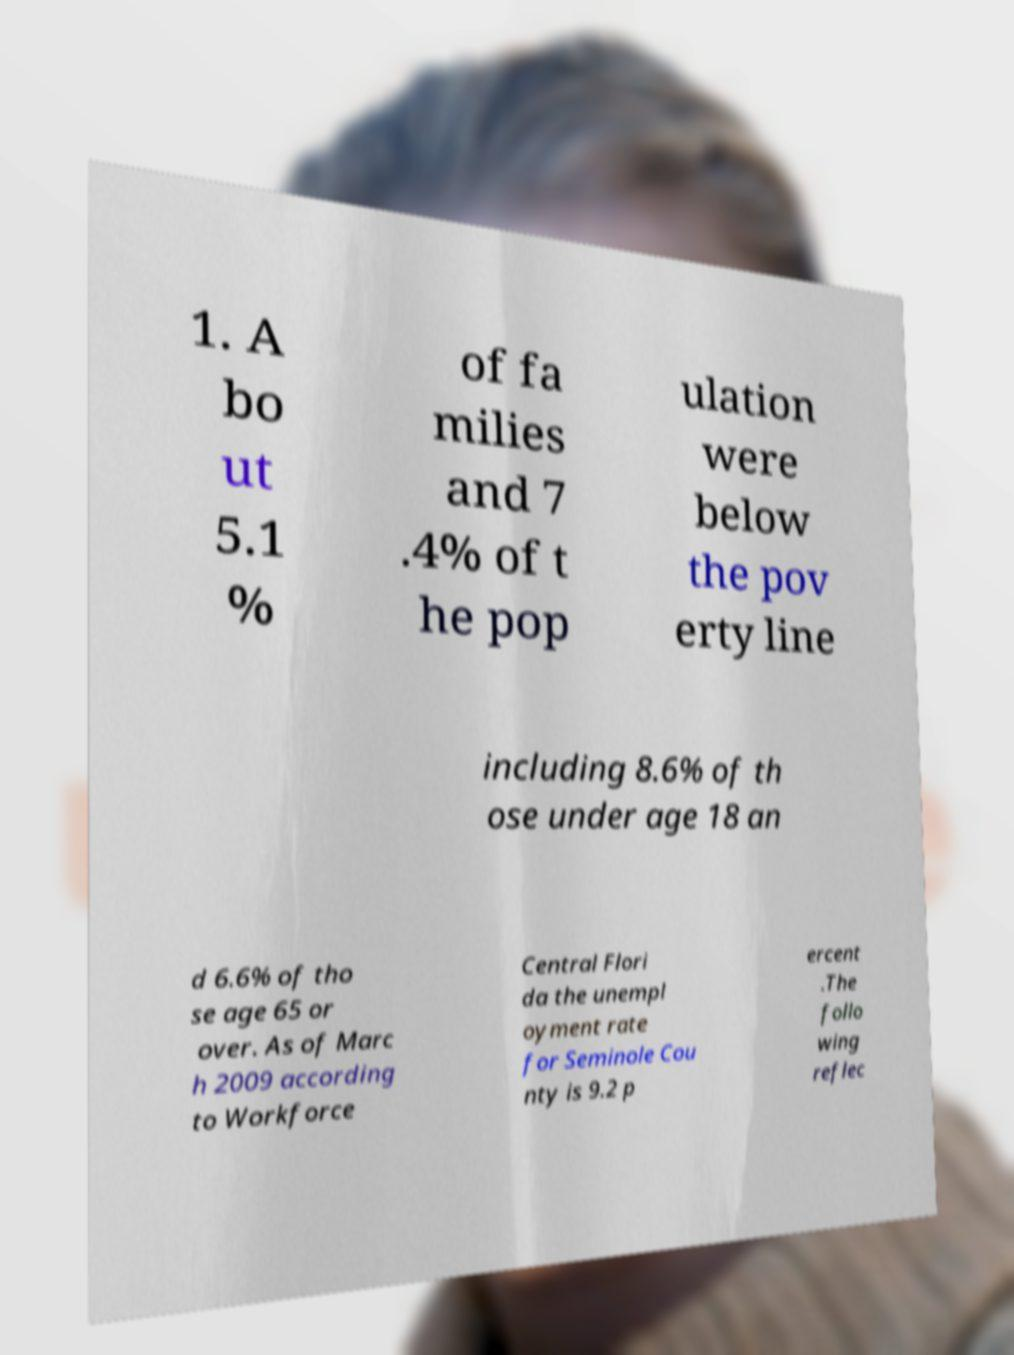There's text embedded in this image that I need extracted. Can you transcribe it verbatim? 1. A bo ut 5.1 % of fa milies and 7 .4% of t he pop ulation were below the pov erty line including 8.6% of th ose under age 18 an d 6.6% of tho se age 65 or over. As of Marc h 2009 according to Workforce Central Flori da the unempl oyment rate for Seminole Cou nty is 9.2 p ercent .The follo wing reflec 